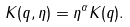Convert formula to latex. <formula><loc_0><loc_0><loc_500><loc_500>K ( q , \eta ) = \eta ^ { \alpha } K ( q ) .</formula> 